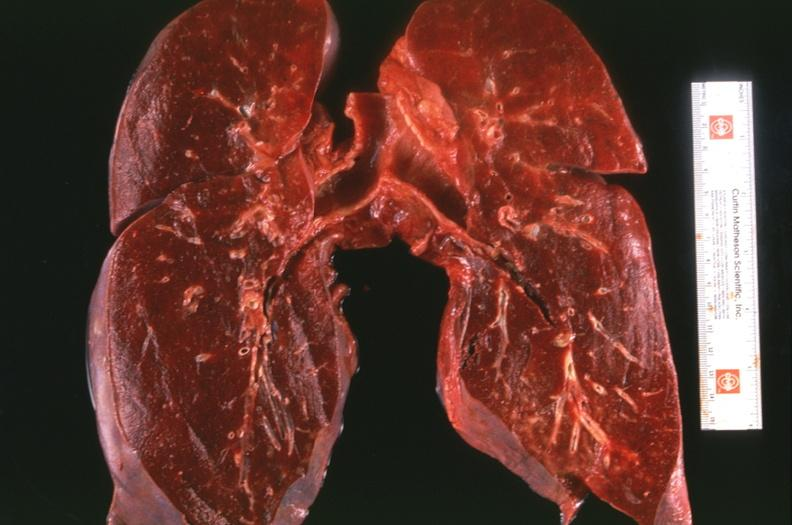does this image show lung, congestion, heart failure cells hemosiderin laden macrophages?
Answer the question using a single word or phrase. Yes 